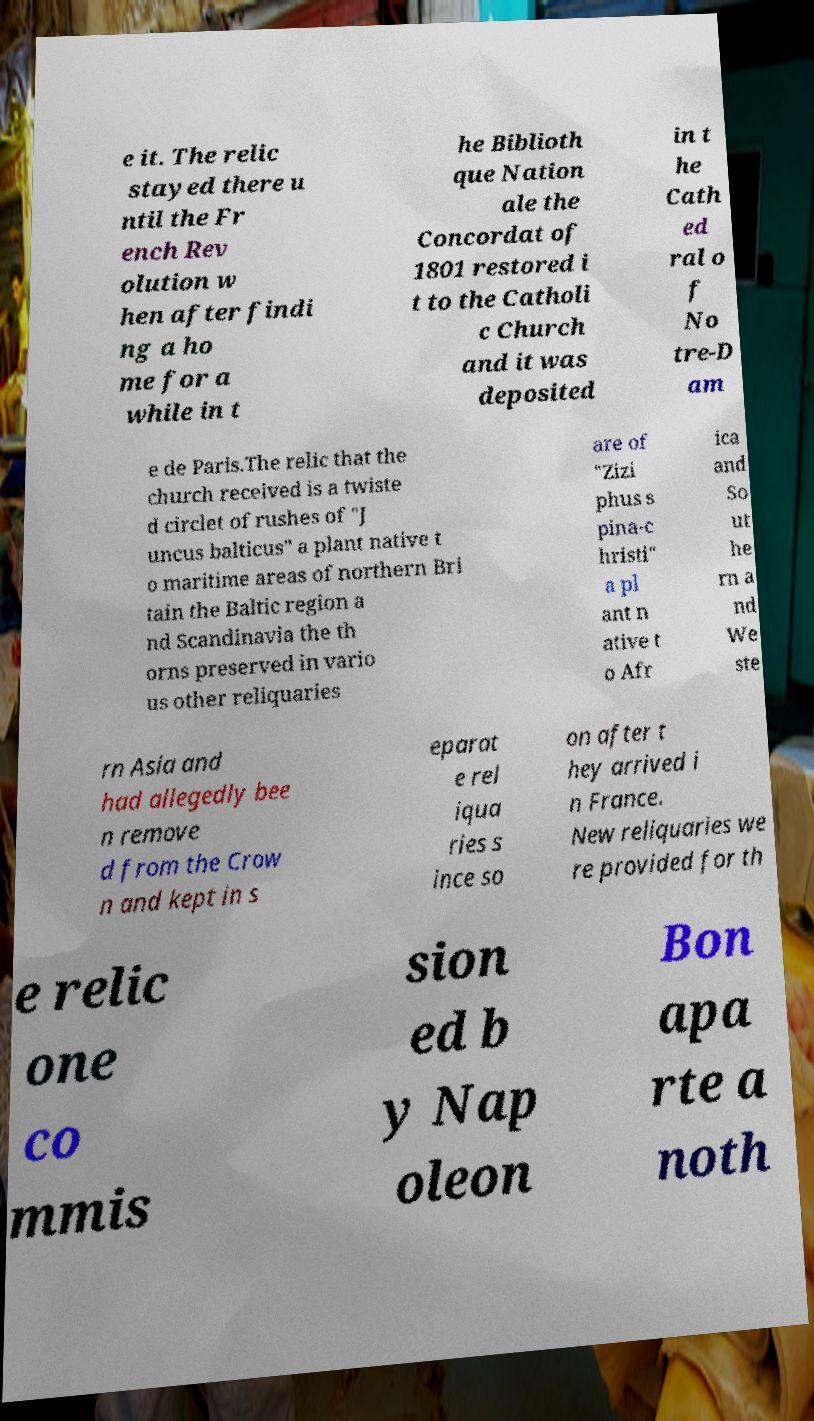There's text embedded in this image that I need extracted. Can you transcribe it verbatim? e it. The relic stayed there u ntil the Fr ench Rev olution w hen after findi ng a ho me for a while in t he Biblioth que Nation ale the Concordat of 1801 restored i t to the Catholi c Church and it was deposited in t he Cath ed ral o f No tre-D am e de Paris.The relic that the church received is a twiste d circlet of rushes of "J uncus balticus" a plant native t o maritime areas of northern Bri tain the Baltic region a nd Scandinavia the th orns preserved in vario us other reliquaries are of "Zizi phus s pina-c hristi" a pl ant n ative t o Afr ica and So ut he rn a nd We ste rn Asia and had allegedly bee n remove d from the Crow n and kept in s eparat e rel iqua ries s ince so on after t hey arrived i n France. New reliquaries we re provided for th e relic one co mmis sion ed b y Nap oleon Bon apa rte a noth 